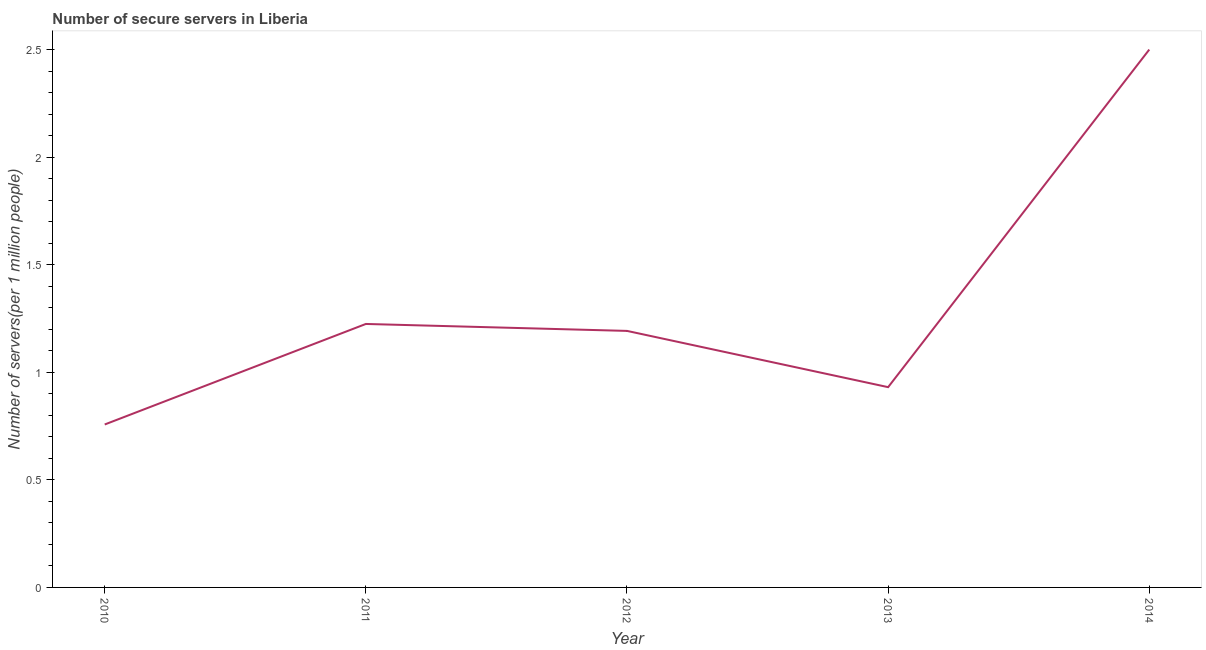What is the number of secure internet servers in 2011?
Ensure brevity in your answer.  1.23. Across all years, what is the maximum number of secure internet servers?
Provide a short and direct response. 2.5. Across all years, what is the minimum number of secure internet servers?
Ensure brevity in your answer.  0.76. In which year was the number of secure internet servers maximum?
Your answer should be very brief. 2014. In which year was the number of secure internet servers minimum?
Make the answer very short. 2010. What is the sum of the number of secure internet servers?
Make the answer very short. 6.61. What is the difference between the number of secure internet servers in 2010 and 2013?
Provide a succinct answer. -0.17. What is the average number of secure internet servers per year?
Ensure brevity in your answer.  1.32. What is the median number of secure internet servers?
Give a very brief answer. 1.19. What is the ratio of the number of secure internet servers in 2011 to that in 2013?
Your answer should be very brief. 1.32. Is the difference between the number of secure internet servers in 2012 and 2013 greater than the difference between any two years?
Offer a very short reply. No. What is the difference between the highest and the second highest number of secure internet servers?
Provide a short and direct response. 1.28. Is the sum of the number of secure internet servers in 2010 and 2013 greater than the maximum number of secure internet servers across all years?
Offer a very short reply. No. What is the difference between the highest and the lowest number of secure internet servers?
Give a very brief answer. 1.74. In how many years, is the number of secure internet servers greater than the average number of secure internet servers taken over all years?
Provide a succinct answer. 1. Does the number of secure internet servers monotonically increase over the years?
Your answer should be compact. No. How many lines are there?
Provide a succinct answer. 1. Are the values on the major ticks of Y-axis written in scientific E-notation?
Provide a succinct answer. No. What is the title of the graph?
Give a very brief answer. Number of secure servers in Liberia. What is the label or title of the Y-axis?
Your answer should be very brief. Number of servers(per 1 million people). What is the Number of servers(per 1 million people) in 2010?
Make the answer very short. 0.76. What is the Number of servers(per 1 million people) of 2011?
Offer a terse response. 1.23. What is the Number of servers(per 1 million people) of 2012?
Offer a very short reply. 1.19. What is the Number of servers(per 1 million people) in 2013?
Provide a succinct answer. 0.93. What is the Number of servers(per 1 million people) in 2014?
Ensure brevity in your answer.  2.5. What is the difference between the Number of servers(per 1 million people) in 2010 and 2011?
Your answer should be compact. -0.47. What is the difference between the Number of servers(per 1 million people) in 2010 and 2012?
Provide a succinct answer. -0.44. What is the difference between the Number of servers(per 1 million people) in 2010 and 2013?
Offer a very short reply. -0.17. What is the difference between the Number of servers(per 1 million people) in 2010 and 2014?
Your answer should be compact. -1.74. What is the difference between the Number of servers(per 1 million people) in 2011 and 2012?
Your response must be concise. 0.03. What is the difference between the Number of servers(per 1 million people) in 2011 and 2013?
Ensure brevity in your answer.  0.29. What is the difference between the Number of servers(per 1 million people) in 2011 and 2014?
Your response must be concise. -1.28. What is the difference between the Number of servers(per 1 million people) in 2012 and 2013?
Offer a very short reply. 0.26. What is the difference between the Number of servers(per 1 million people) in 2012 and 2014?
Provide a short and direct response. -1.31. What is the difference between the Number of servers(per 1 million people) in 2013 and 2014?
Give a very brief answer. -1.57. What is the ratio of the Number of servers(per 1 million people) in 2010 to that in 2011?
Make the answer very short. 0.62. What is the ratio of the Number of servers(per 1 million people) in 2010 to that in 2012?
Offer a very short reply. 0.64. What is the ratio of the Number of servers(per 1 million people) in 2010 to that in 2013?
Offer a terse response. 0.81. What is the ratio of the Number of servers(per 1 million people) in 2010 to that in 2014?
Provide a succinct answer. 0.3. What is the ratio of the Number of servers(per 1 million people) in 2011 to that in 2012?
Your answer should be very brief. 1.03. What is the ratio of the Number of servers(per 1 million people) in 2011 to that in 2013?
Provide a short and direct response. 1.32. What is the ratio of the Number of servers(per 1 million people) in 2011 to that in 2014?
Give a very brief answer. 0.49. What is the ratio of the Number of servers(per 1 million people) in 2012 to that in 2013?
Ensure brevity in your answer.  1.28. What is the ratio of the Number of servers(per 1 million people) in 2012 to that in 2014?
Your answer should be compact. 0.48. What is the ratio of the Number of servers(per 1 million people) in 2013 to that in 2014?
Your answer should be very brief. 0.37. 